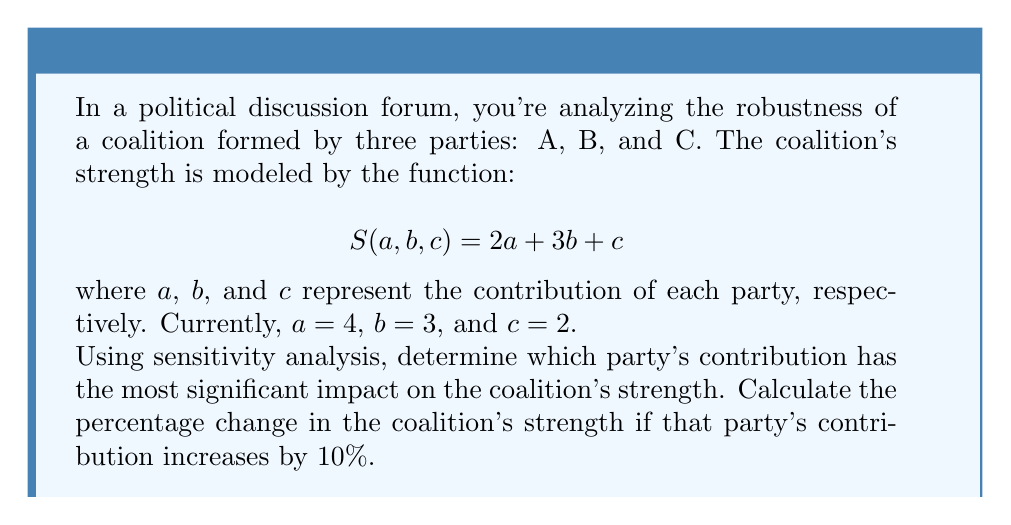Can you answer this question? To determine which party's contribution has the most significant impact on the coalition's strength, we need to calculate the partial derivatives of $S$ with respect to each variable:

1) $\frac{\partial S}{\partial a} = 2$
2) $\frac{\partial S}{\partial b} = 3$
3) $\frac{\partial S}{\partial c} = 1$

The largest partial derivative is $\frac{\partial S}{\partial b} = 3$, indicating that party B's contribution has the most significant impact on the coalition's strength.

To calculate the percentage change if party B's contribution increases by 10%:

1) Current strength: $S(4,3,2) = 2(4) + 3(3) + 2 = 19$

2) New value of $b$ after 10% increase: $3 * 1.1 = 3.3$

3) New strength: $S(4,3.3,2) = 2(4) + 3(3.3) + 2 = 19.9$

4) Absolute change: $19.9 - 19 = 0.9$

5) Percentage change: $\frac{0.9}{19} * 100\% = 4.74\%$
Answer: 4.74% 